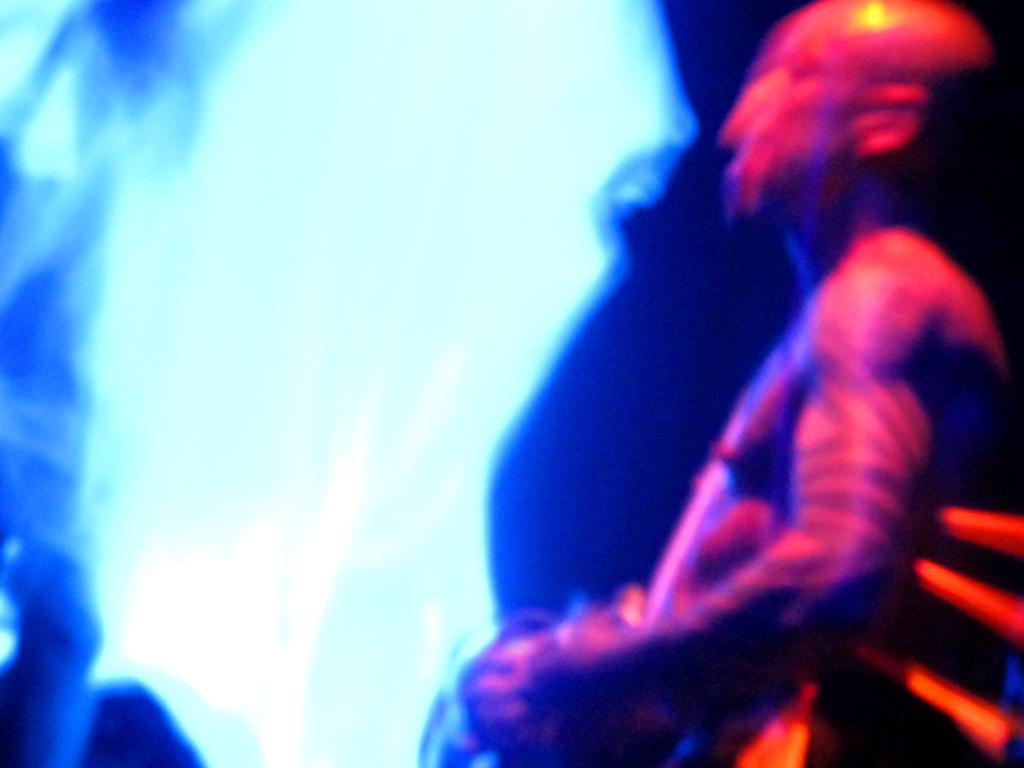What can be observed about the lighting in the image? The image has light effects. Where is the person located in the image? The person is standing on the right side of the image. What is the person holding in the image? The person is holding an object. What type of door can be seen in the image? There is no door present in the image. Can you tell me how many uncles are in the image? There is no reference to an uncle or any family members in the image. 